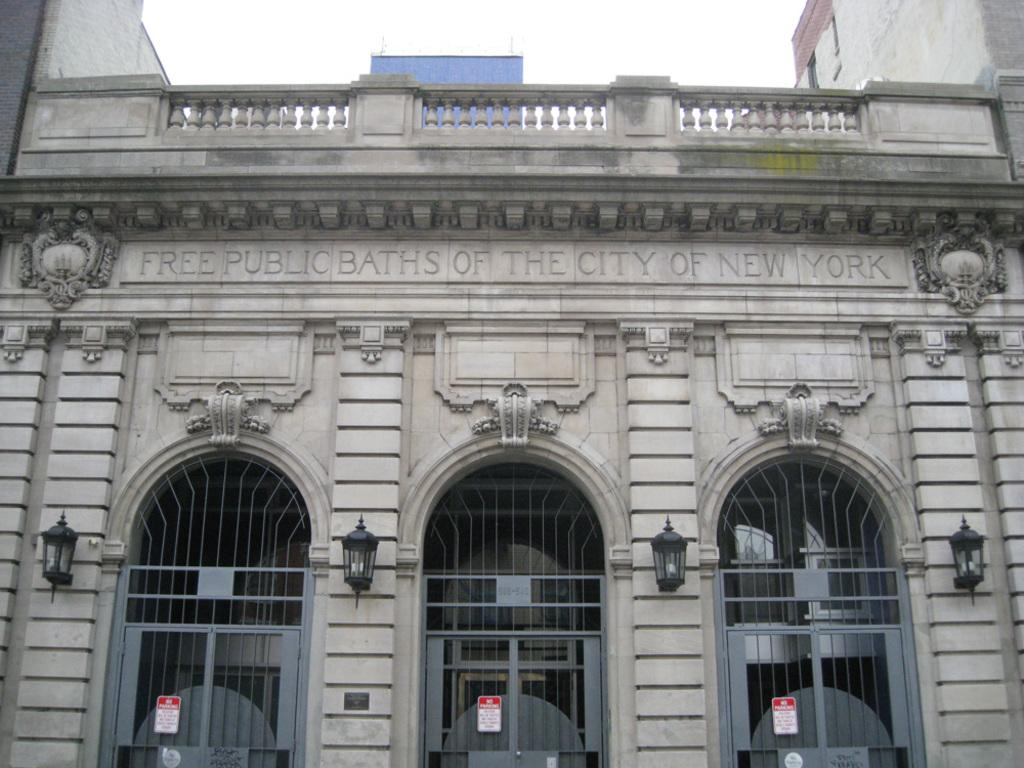What is the main structure in the center of the image? There is a building in the center of the image. What can be found at the bottom of the image? There are doors and lights at the bottom of the image. What is written or displayed on the building? There is text on the building. What additional features are present on the building? There are boards and railing on the building. What is visible at the top of the image? The sky is visible at the top of the image. How many alleys can be seen connecting to the building in the image? There are no alleys present in the image; it only features a building with various elements. 